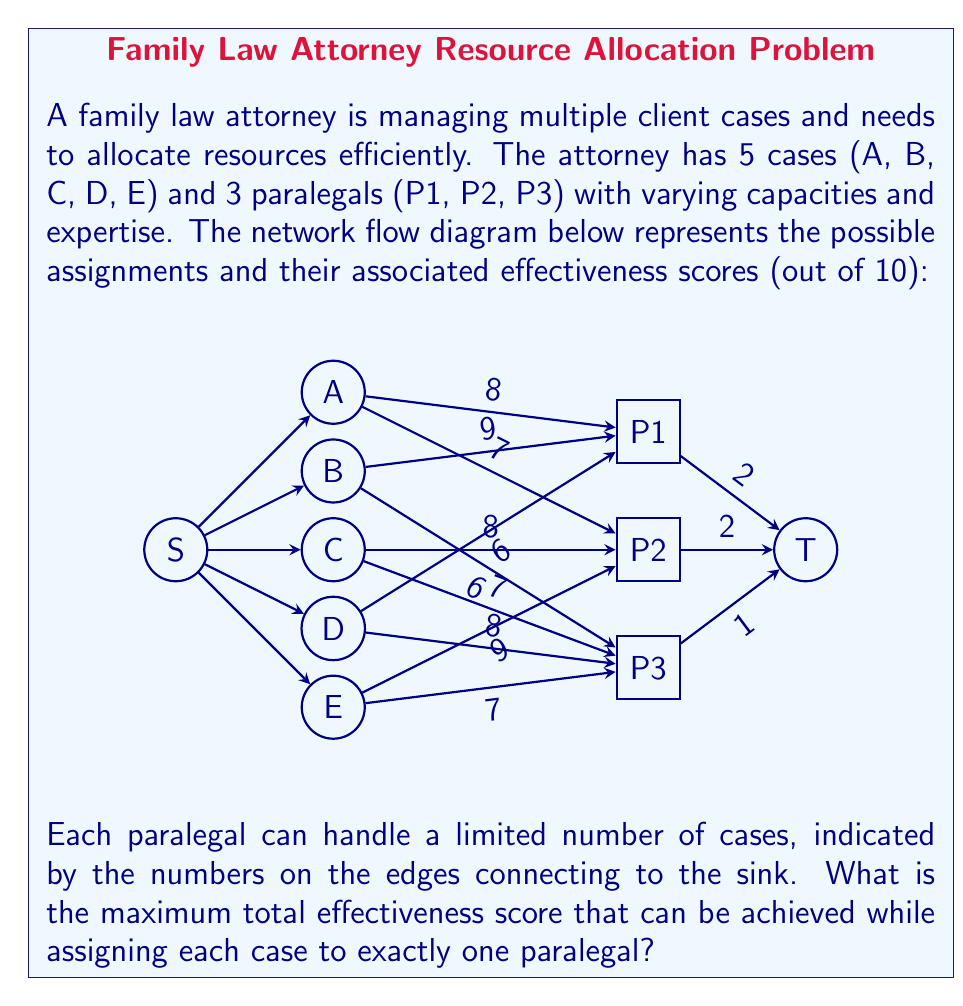Help me with this question. To solve this problem, we'll use the maximum flow algorithm with the objective of maximizing the total effectiveness score. Here's a step-by-step approach:

1) First, we need to convert the effectiveness scores to flow capacities. Since we want to maximize the score, we'll use the scores directly as capacities.

2) The source node connects to all cases with infinite capacity (as each case must be assigned).

3) Each paralegal has a limited capacity (P1: 2, P2: 2, P3: 1) indicated by the edges to the sink.

4) We'll use the Ford-Fulkerson algorithm to find the maximum flow:

   Iteration 1: Path S-A-P1-T, Flow: 2, Total: 2
   Iteration 2: Path S-B-P2-T, Flow: 2, Total: 4
   Iteration 3: Path S-C-P3-T, Flow: 1, Total: 5

5) At this point, all paralegals are at full capacity. The current assignment is:
   P1: Case A (8)
   P2: Case B (9)
   P3: Case C (7)

6) However, we can improve this by using the augmenting path:
   S-D-P3-C-P1-A-P2-T

   This path allows us to reassign Case C to P1, freeing up P3 to take Case D.

7) After this augmentation, the final assignment is:
   P1: Case C (8)
   P2: Case B (9)
   P3: Case D (8)

8) The total effectiveness score is thus: 8 + 9 + 8 = 25

This assignment maximizes the total effectiveness score while respecting the capacity constraints of the paralegals and ensuring each case is assigned to exactly one paralegal.
Answer: 25 